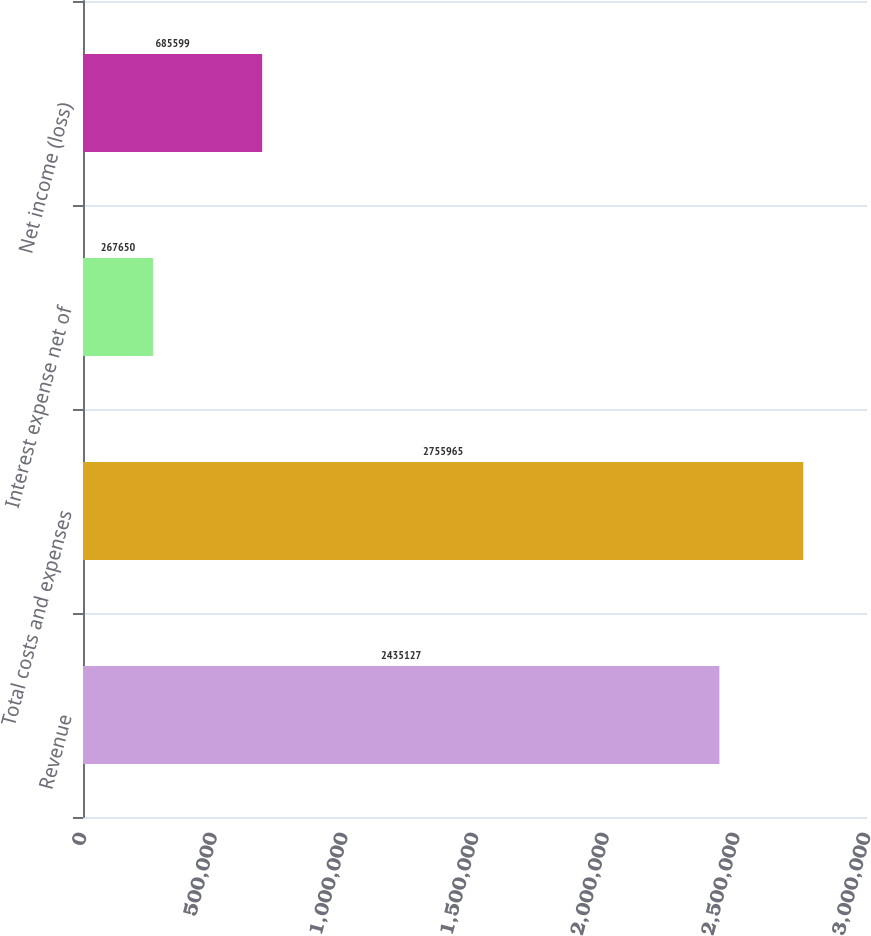Convert chart to OTSL. <chart><loc_0><loc_0><loc_500><loc_500><bar_chart><fcel>Revenue<fcel>Total costs and expenses<fcel>Interest expense net of<fcel>Net income (loss)<nl><fcel>2.43513e+06<fcel>2.75596e+06<fcel>267650<fcel>685599<nl></chart> 